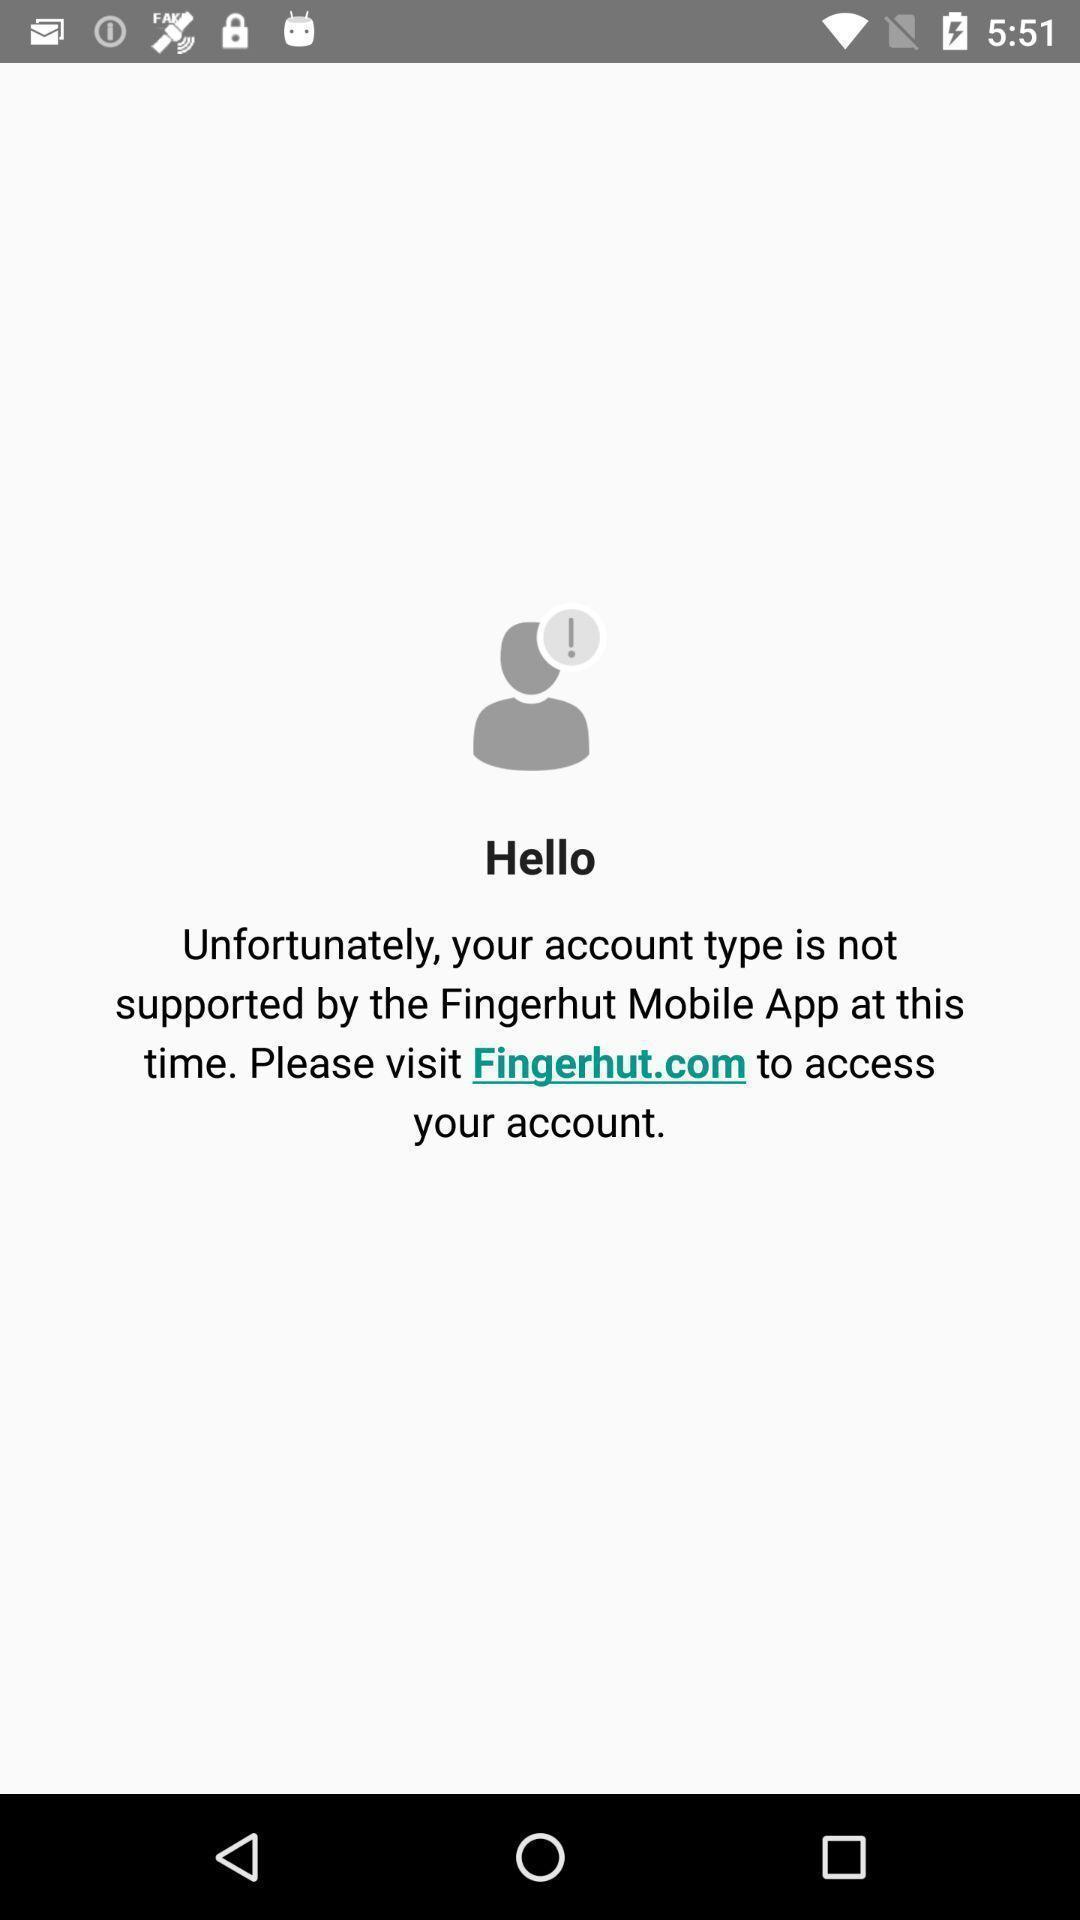Explain the elements present in this screenshot. Page with message for accessing the app. 